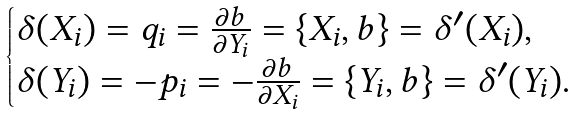<formula> <loc_0><loc_0><loc_500><loc_500>\begin{cases} \delta ( X _ { i } ) = q _ { i } = \frac { \partial b } { \partial Y _ { i } } = \{ X _ { i } , b \} = \delta ^ { \prime } ( X _ { i } ) , \\ \delta ( Y _ { i } ) = - p _ { i } = - \frac { \partial b } { \partial X _ { i } } = \{ Y _ { i } , b \} = \delta ^ { \prime } ( Y _ { i } ) . \end{cases}</formula> 